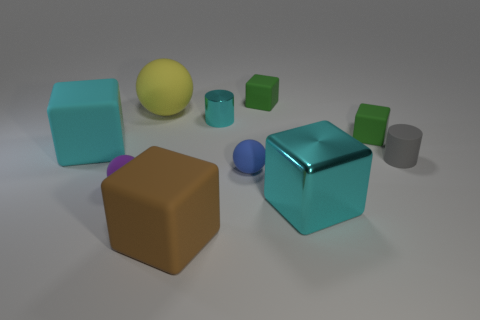Do the cyan metallic cube and the matte cube that is in front of the large cyan rubber thing have the same size? While both cubes appear similar at first glance, upon closer inspection, it's clear that the cyan metallic cube is slightly larger than the matte cube. The play of light and shadows, combined with the perspective in the image, can make it challenging to determine size with absolute certainty, but relative to their surroundings it seems that they are not the same size. 